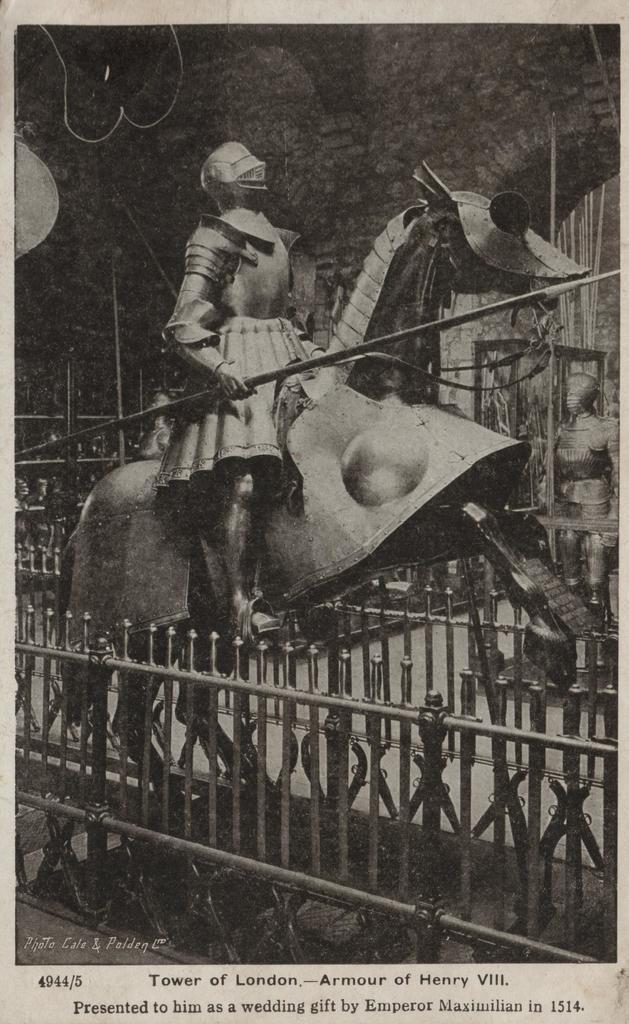In one or two sentences, can you explain what this image depicts? This is a black and white image. In this image we can see some statues and a fence around it. On the backside we can see a wall. On the bottom of the image we can see some text. 